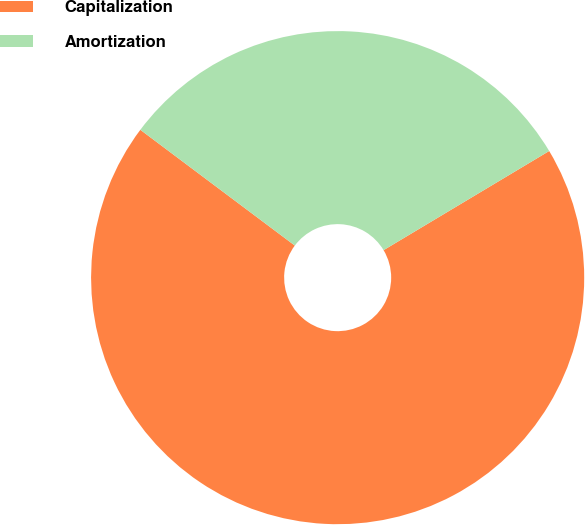Convert chart to OTSL. <chart><loc_0><loc_0><loc_500><loc_500><pie_chart><fcel>Capitalization<fcel>Amortization<nl><fcel>68.82%<fcel>31.18%<nl></chart> 